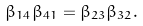<formula> <loc_0><loc_0><loc_500><loc_500>\beta _ { 1 4 } \beta _ { 4 1 } = \beta _ { 2 3 } \beta _ { 3 2 } .</formula> 